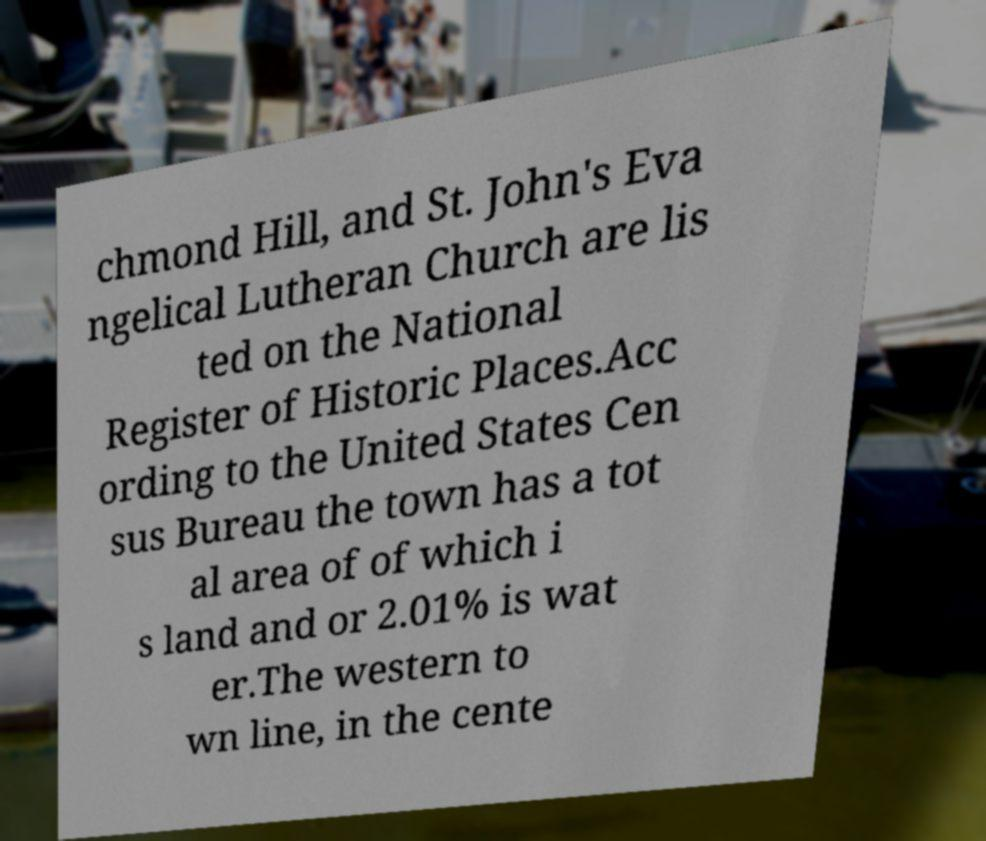Can you accurately transcribe the text from the provided image for me? chmond Hill, and St. John's Eva ngelical Lutheran Church are lis ted on the National Register of Historic Places.Acc ording to the United States Cen sus Bureau the town has a tot al area of of which i s land and or 2.01% is wat er.The western to wn line, in the cente 